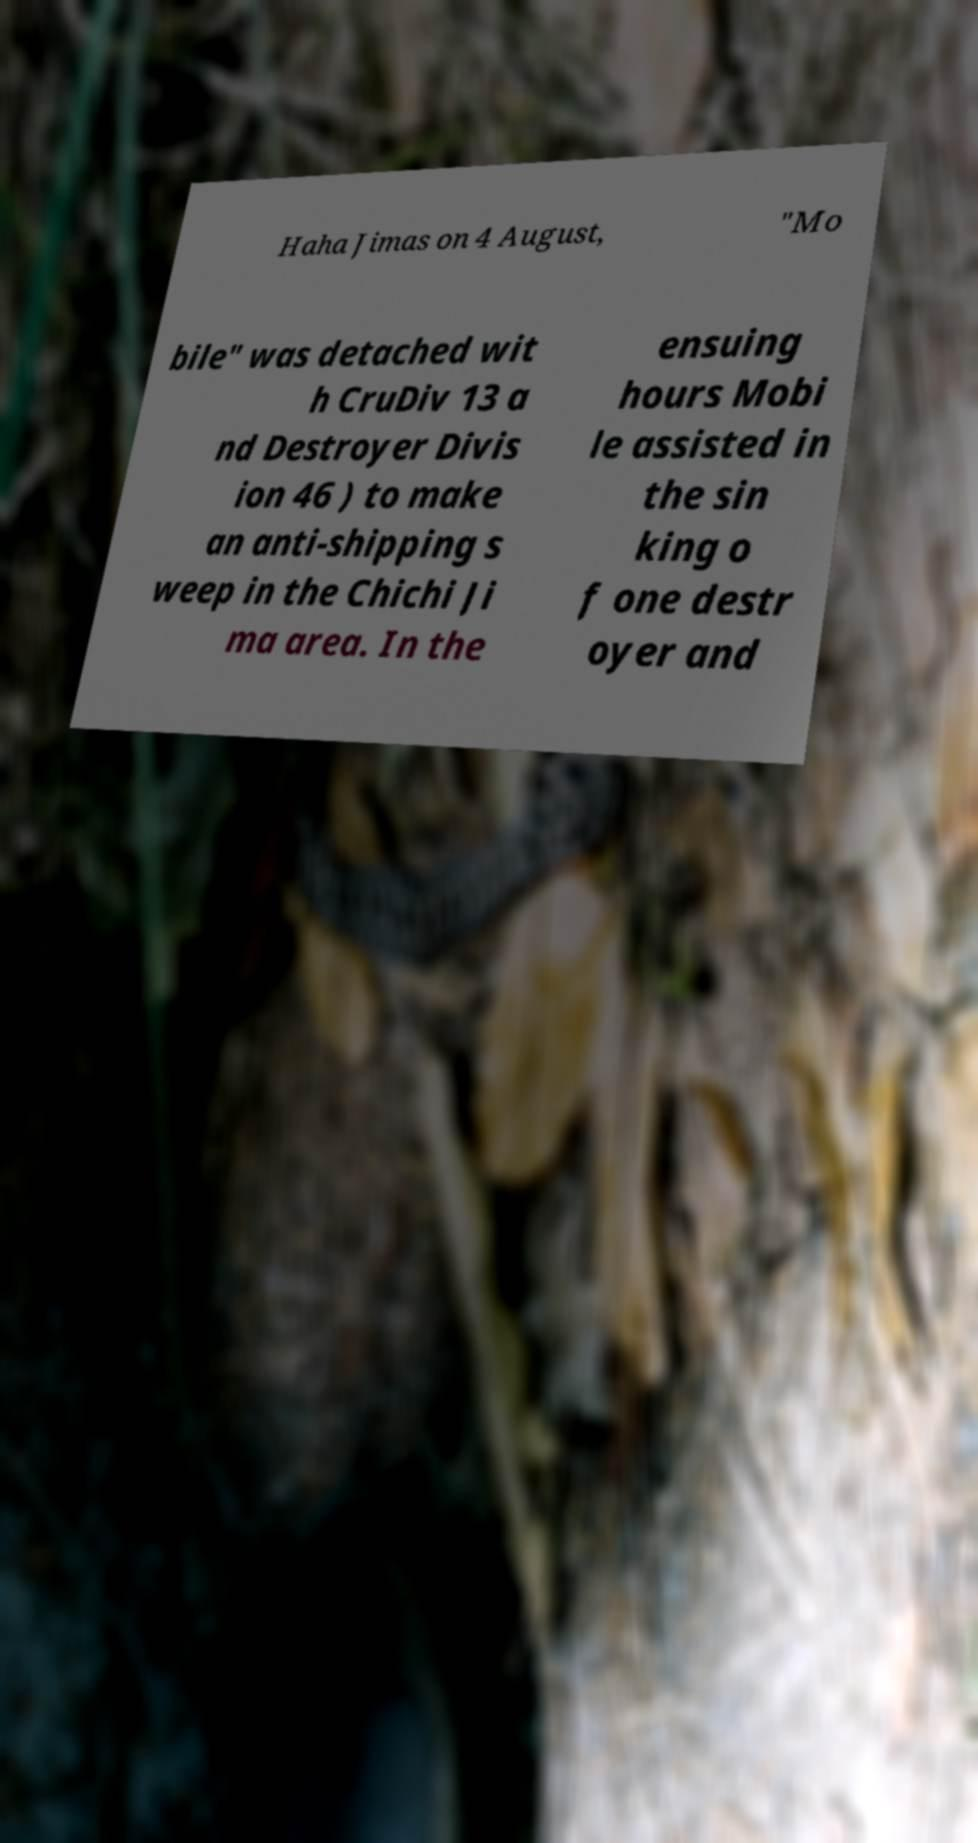I need the written content from this picture converted into text. Can you do that? Haha Jimas on 4 August, "Mo bile" was detached wit h CruDiv 13 a nd Destroyer Divis ion 46 ) to make an anti-shipping s weep in the Chichi Ji ma area. In the ensuing hours Mobi le assisted in the sin king o f one destr oyer and 